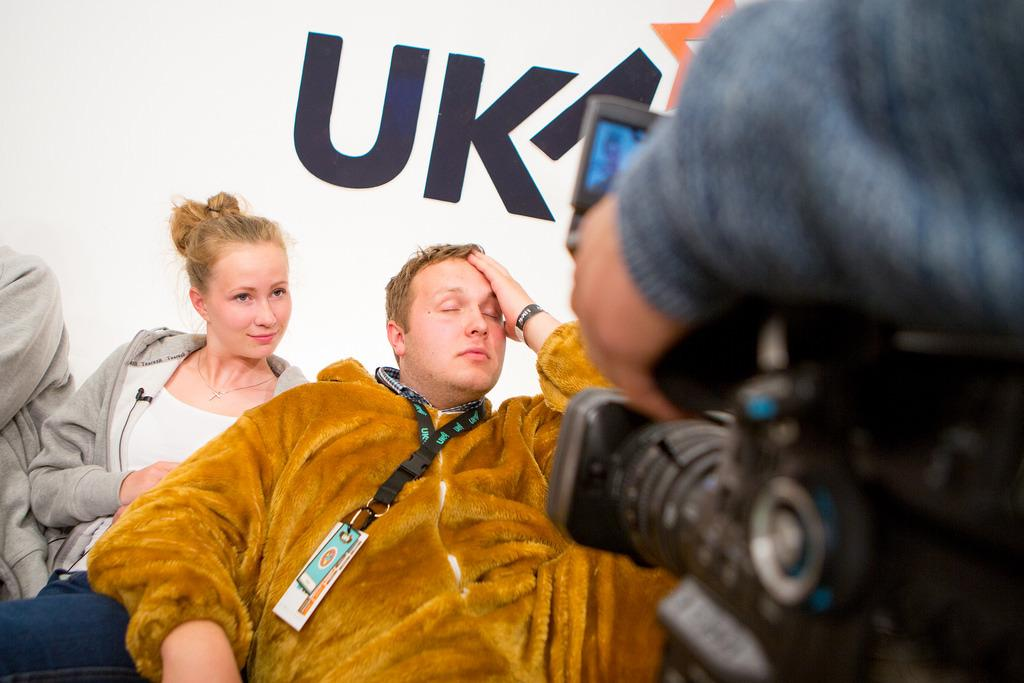What are the people in the image doing? The people in the image are sitting. Can you describe the man in the foreground? The man in the foreground is holding a camera. What can be seen in the background of the image? There is some text visible in the background. Where is the girl sitting in the image? There is no girl present in the image. What type of cannon is being used by the man in the image? There is no cannon present in the image; the man is holding a camera. 